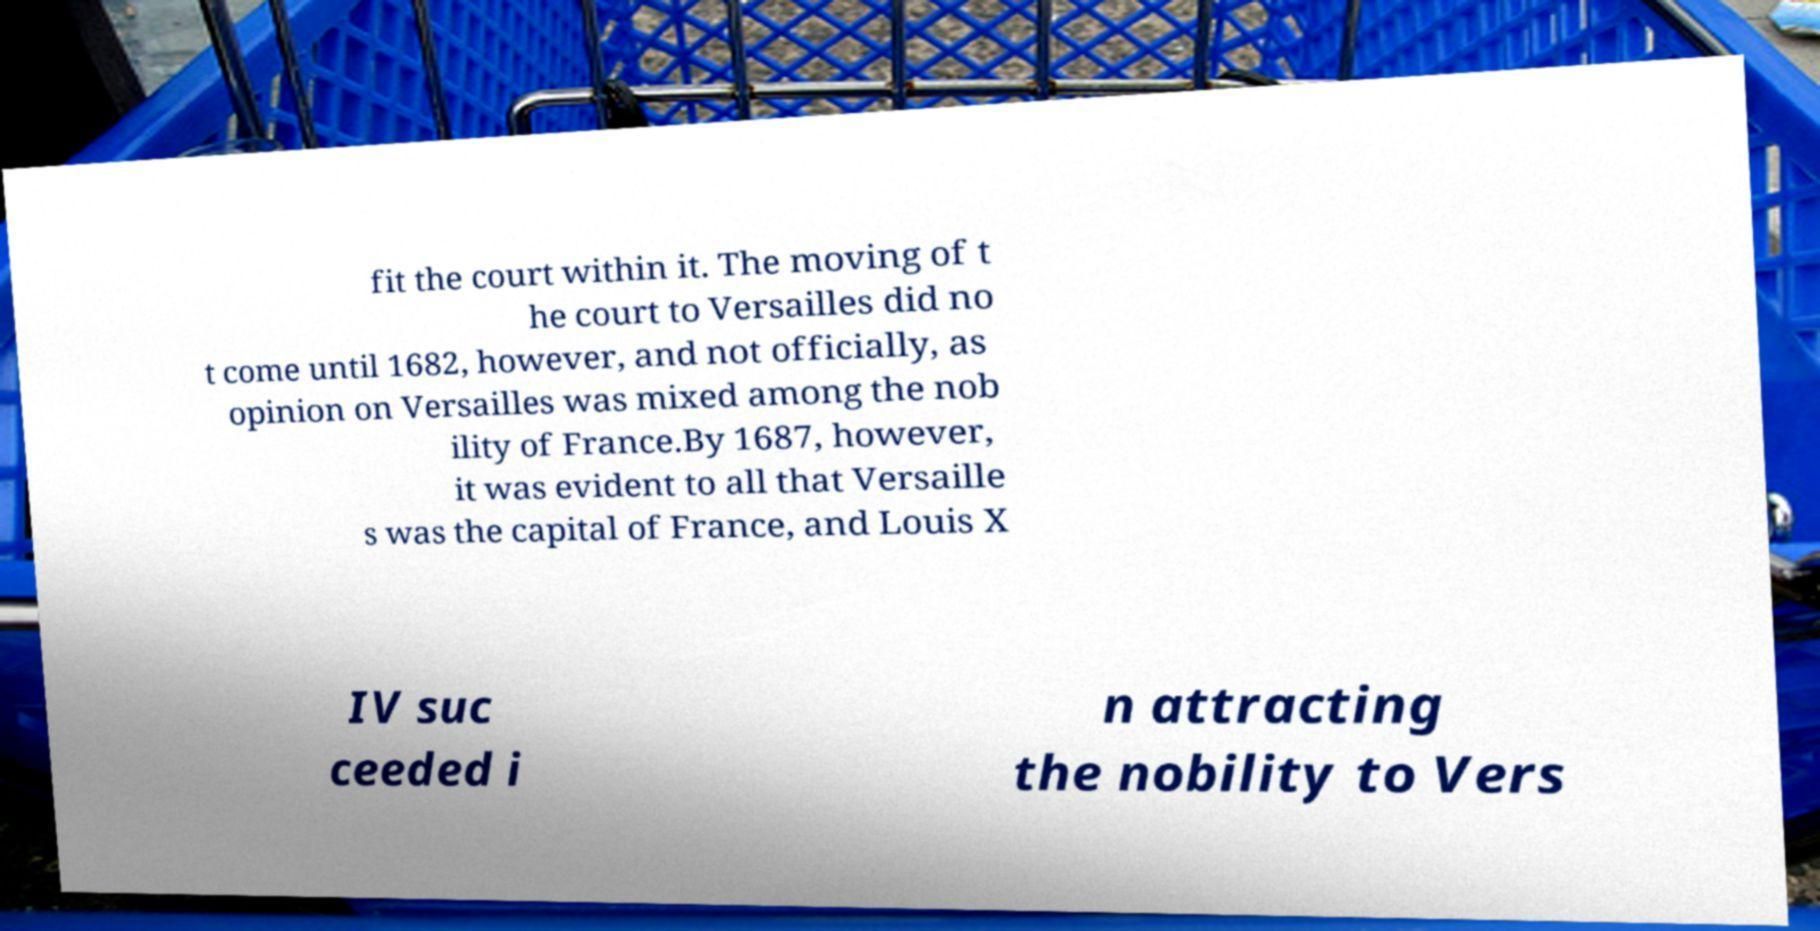Can you read and provide the text displayed in the image?This photo seems to have some interesting text. Can you extract and type it out for me? fit the court within it. The moving of t he court to Versailles did no t come until 1682, however, and not officially, as opinion on Versailles was mixed among the nob ility of France.By 1687, however, it was evident to all that Versaille s was the capital of France, and Louis X IV suc ceeded i n attracting the nobility to Vers 